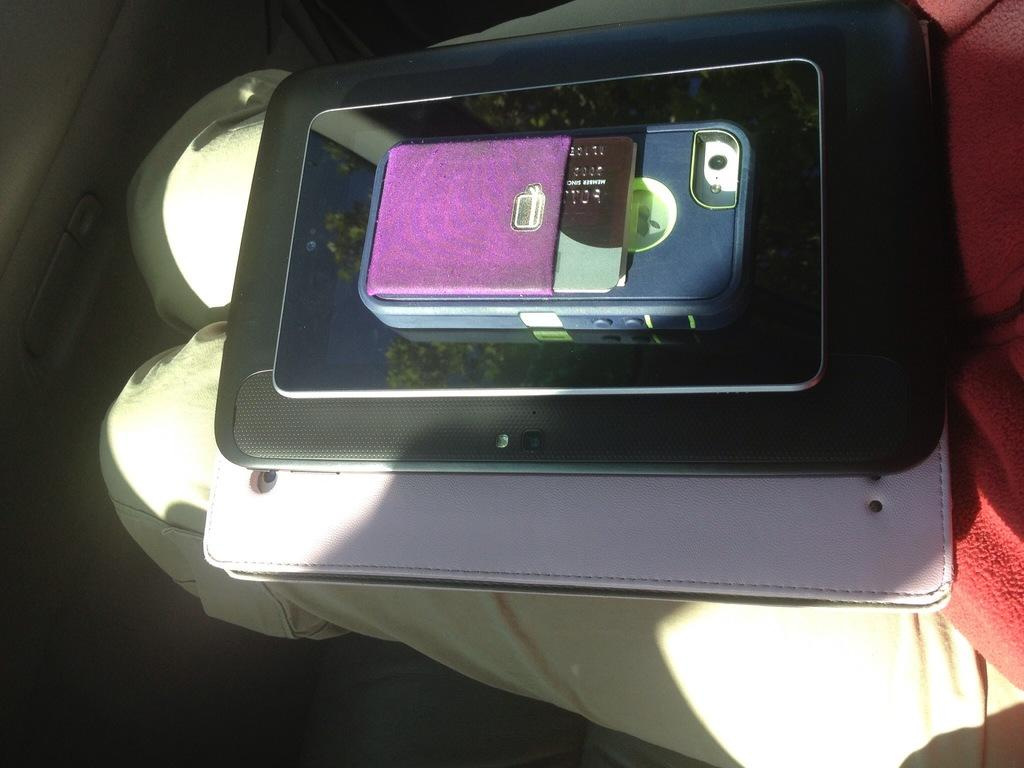What type of objects are present in the image? There are electronic devices in the image. Is there anything placed on top of the electronic devices? Yes, there is a card on top of the electronic devices. What color is the cloth visible in the background? The cloth in the background is red. What type of clothing can be seen in the background? There is a pant in the background. How many girls are ringing bells in the image? There are no girls or bells present in the image. 